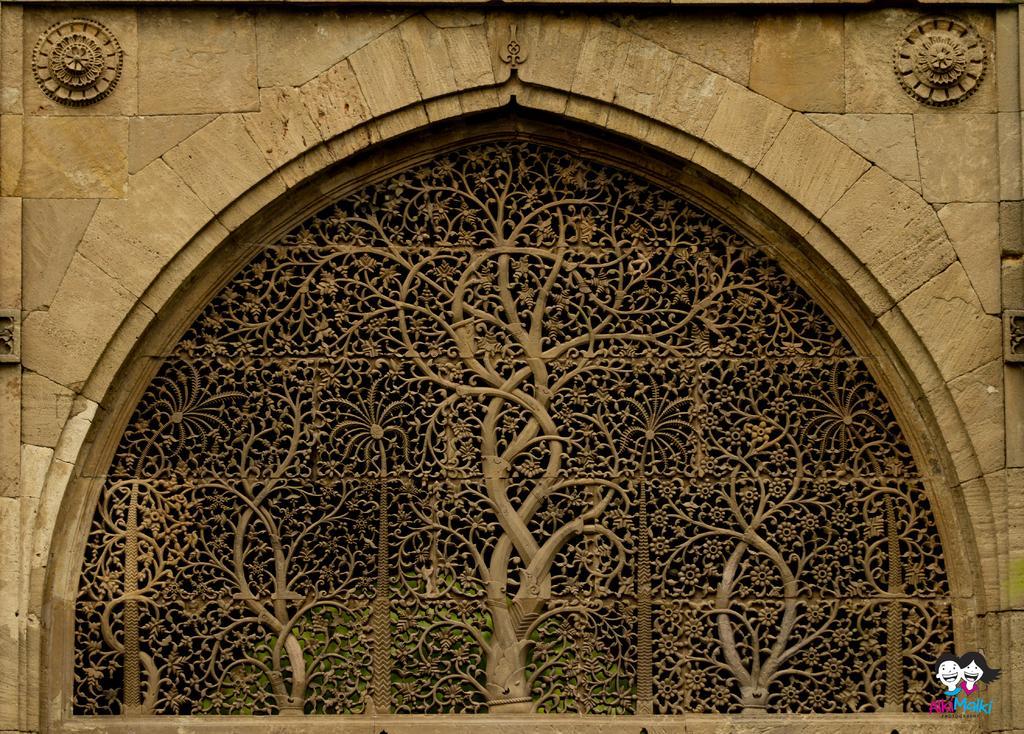Can you describe this image briefly? In this image I can see a carved window to the wall. At the bottom right-hand corner there is a logo. 